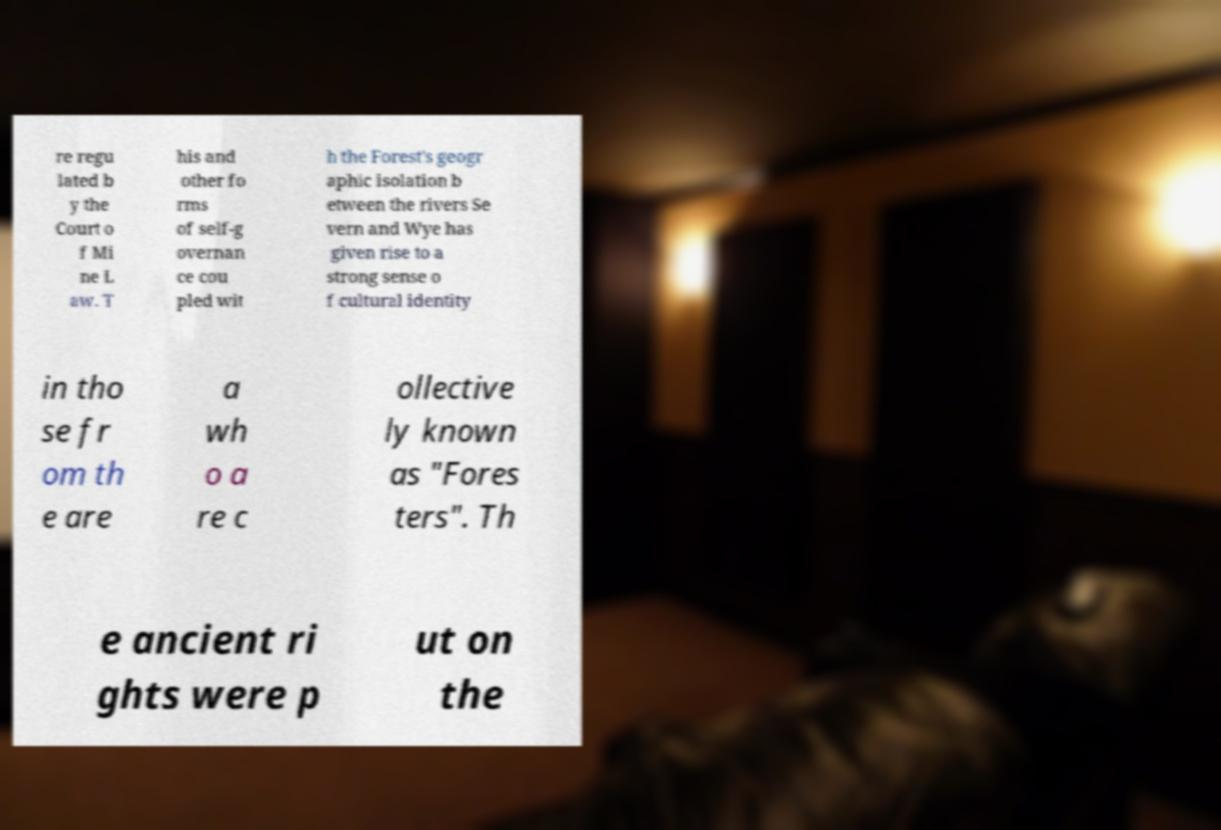For documentation purposes, I need the text within this image transcribed. Could you provide that? re regu lated b y the Court o f Mi ne L aw. T his and other fo rms of self-g overnan ce cou pled wit h the Forest's geogr aphic isolation b etween the rivers Se vern and Wye has given rise to a strong sense o f cultural identity in tho se fr om th e are a wh o a re c ollective ly known as "Fores ters". Th e ancient ri ghts were p ut on the 